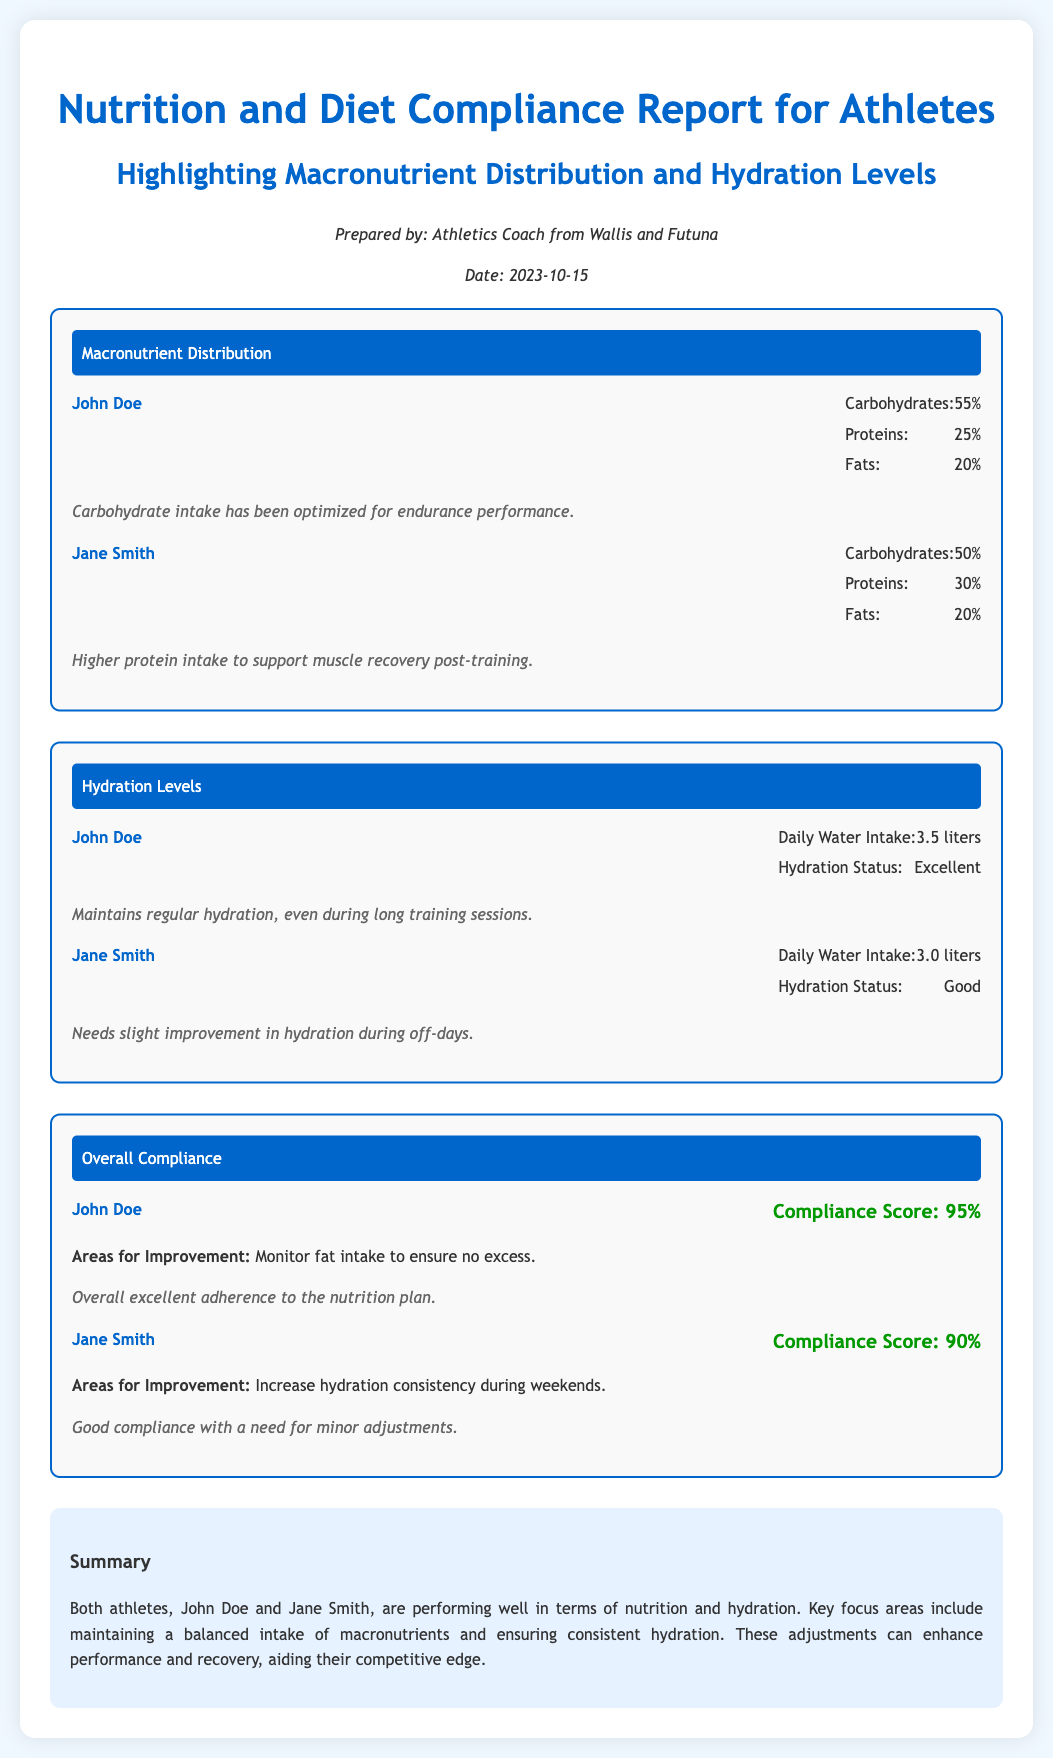What is the date of the report? The date of the report is mentioned in the document as October 15, 2023.
Answer: October 15, 2023 What is John Doe's carbohydrate intake percentage? John Doe's carbohydrate intake percentage is listed under macronutrient distribution in the document.
Answer: 55% What is Jane Smith's compliance score? Jane Smith's compliance score is found in the overall compliance section of the document.
Answer: 90% What is the daily water intake of John Doe? The daily water intake for John Doe can be found in the hydration levels section of the document.
Answer: 3.5 liters What are the areas for improvement for John Doe? The areas for improvement for John Doe are detailed in the overall compliance section.
Answer: Monitor fat intake to ensure no excess What is the macronutrient distribution for Jane Smith? The macronutrient distribution for Jane Smith is outlined in the macronutrient distribution section.
Answer: 50% carbohydrates, 30% proteins, 20% fats What hydration status does Jane Smith have? Jane Smith's hydration status is specified in the hydration levels section of the document.
Answer: Good What key focus areas are highlighted in the summary? The summary outlines key focus areas for nutrition and hydration adjustments for both athletes.
Answer: Balanced intake of macronutrients and consistent hydration 